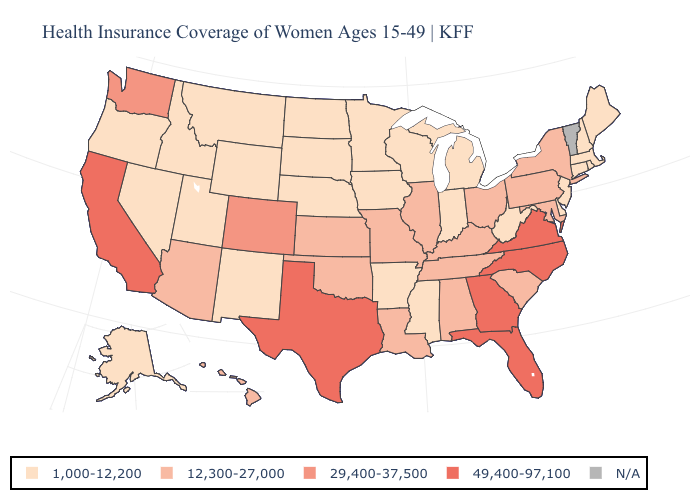What is the lowest value in states that border Indiana?
Give a very brief answer. 1,000-12,200. What is the value of Oklahoma?
Short answer required. 12,300-27,000. Does Nebraska have the highest value in the USA?
Short answer required. No. What is the value of Oklahoma?
Answer briefly. 12,300-27,000. Name the states that have a value in the range 29,400-37,500?
Give a very brief answer. Colorado, Washington. Name the states that have a value in the range 49,400-97,100?
Give a very brief answer. California, Florida, Georgia, North Carolina, Texas, Virginia. Name the states that have a value in the range 1,000-12,200?
Keep it brief. Alaska, Arkansas, Connecticut, Delaware, Idaho, Indiana, Iowa, Maine, Massachusetts, Michigan, Minnesota, Mississippi, Montana, Nebraska, Nevada, New Hampshire, New Jersey, New Mexico, North Dakota, Oregon, Rhode Island, South Dakota, Utah, West Virginia, Wisconsin, Wyoming. What is the highest value in the USA?
Write a very short answer. 49,400-97,100. What is the value of New Jersey?
Quick response, please. 1,000-12,200. Name the states that have a value in the range 49,400-97,100?
Write a very short answer. California, Florida, Georgia, North Carolina, Texas, Virginia. What is the highest value in states that border Arizona?
Answer briefly. 49,400-97,100. Name the states that have a value in the range 29,400-37,500?
Short answer required. Colorado, Washington. What is the value of Wisconsin?
Give a very brief answer. 1,000-12,200. 